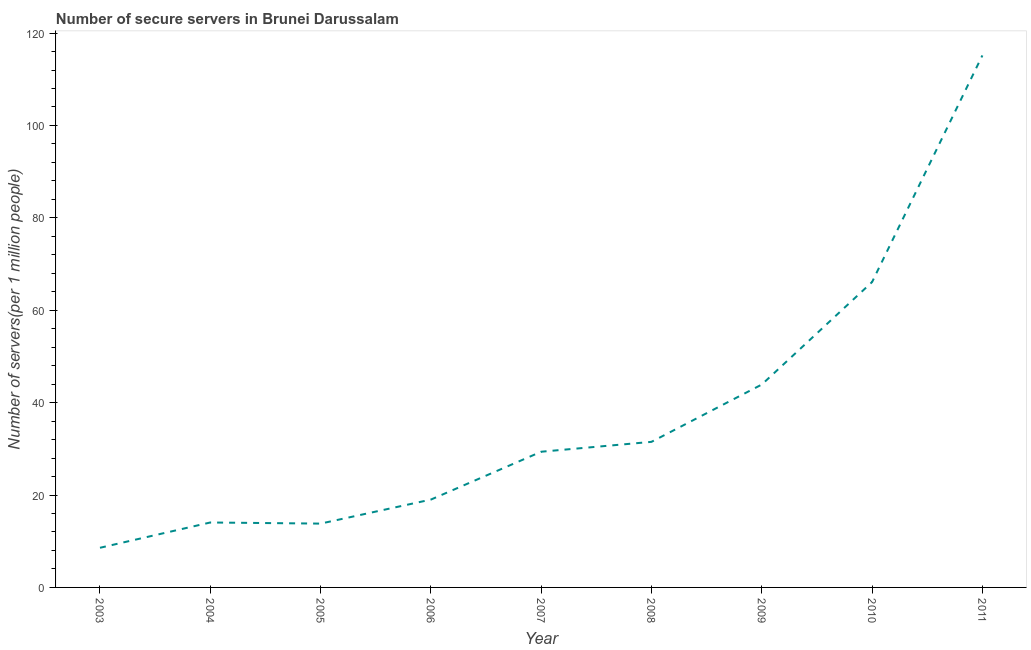What is the number of secure internet servers in 2005?
Provide a succinct answer. 13.82. Across all years, what is the maximum number of secure internet servers?
Provide a succinct answer. 115.16. Across all years, what is the minimum number of secure internet servers?
Offer a very short reply. 8.58. In which year was the number of secure internet servers minimum?
Your response must be concise. 2003. What is the sum of the number of secure internet servers?
Your answer should be compact. 341.54. What is the difference between the number of secure internet servers in 2005 and 2006?
Your answer should be compact. -5.2. What is the average number of secure internet servers per year?
Offer a terse response. 37.95. What is the median number of secure internet servers?
Offer a terse response. 29.38. Do a majority of the years between 2009 and 2007 (inclusive) have number of secure internet servers greater than 32 ?
Offer a very short reply. No. What is the ratio of the number of secure internet servers in 2004 to that in 2007?
Give a very brief answer. 0.48. Is the number of secure internet servers in 2004 less than that in 2005?
Offer a very short reply. No. Is the difference between the number of secure internet servers in 2003 and 2006 greater than the difference between any two years?
Ensure brevity in your answer.  No. What is the difference between the highest and the second highest number of secure internet servers?
Make the answer very short. 49.05. What is the difference between the highest and the lowest number of secure internet servers?
Offer a terse response. 106.58. In how many years, is the number of secure internet servers greater than the average number of secure internet servers taken over all years?
Your answer should be very brief. 3. How many lines are there?
Give a very brief answer. 1. How many years are there in the graph?
Your answer should be compact. 9. Does the graph contain any zero values?
Offer a terse response. No. What is the title of the graph?
Your response must be concise. Number of secure servers in Brunei Darussalam. What is the label or title of the X-axis?
Your response must be concise. Year. What is the label or title of the Y-axis?
Provide a short and direct response. Number of servers(per 1 million people). What is the Number of servers(per 1 million people) in 2003?
Your response must be concise. 8.58. What is the Number of servers(per 1 million people) in 2004?
Offer a very short reply. 14.06. What is the Number of servers(per 1 million people) in 2005?
Provide a succinct answer. 13.82. What is the Number of servers(per 1 million people) of 2006?
Provide a succinct answer. 19.01. What is the Number of servers(per 1 million people) in 2007?
Make the answer very short. 29.38. What is the Number of servers(per 1 million people) in 2008?
Ensure brevity in your answer.  31.51. What is the Number of servers(per 1 million people) in 2009?
Your answer should be very brief. 43.92. What is the Number of servers(per 1 million people) in 2010?
Make the answer very short. 66.11. What is the Number of servers(per 1 million people) in 2011?
Your answer should be compact. 115.16. What is the difference between the Number of servers(per 1 million people) in 2003 and 2004?
Your answer should be compact. -5.47. What is the difference between the Number of servers(per 1 million people) in 2003 and 2005?
Offer a terse response. -5.23. What is the difference between the Number of servers(per 1 million people) in 2003 and 2006?
Provide a short and direct response. -10.43. What is the difference between the Number of servers(per 1 million people) in 2003 and 2007?
Your response must be concise. -20.79. What is the difference between the Number of servers(per 1 million people) in 2003 and 2008?
Provide a succinct answer. -22.93. What is the difference between the Number of servers(per 1 million people) in 2003 and 2009?
Provide a short and direct response. -35.34. What is the difference between the Number of servers(per 1 million people) in 2003 and 2010?
Keep it short and to the point. -57.52. What is the difference between the Number of servers(per 1 million people) in 2003 and 2011?
Offer a terse response. -106.58. What is the difference between the Number of servers(per 1 million people) in 2004 and 2005?
Keep it short and to the point. 0.24. What is the difference between the Number of servers(per 1 million people) in 2004 and 2006?
Offer a terse response. -4.96. What is the difference between the Number of servers(per 1 million people) in 2004 and 2007?
Make the answer very short. -15.32. What is the difference between the Number of servers(per 1 million people) in 2004 and 2008?
Make the answer very short. -17.46. What is the difference between the Number of servers(per 1 million people) in 2004 and 2009?
Your answer should be compact. -29.86. What is the difference between the Number of servers(per 1 million people) in 2004 and 2010?
Keep it short and to the point. -52.05. What is the difference between the Number of servers(per 1 million people) in 2004 and 2011?
Ensure brevity in your answer.  -101.1. What is the difference between the Number of servers(per 1 million people) in 2005 and 2006?
Offer a terse response. -5.2. What is the difference between the Number of servers(per 1 million people) in 2005 and 2007?
Offer a terse response. -15.56. What is the difference between the Number of servers(per 1 million people) in 2005 and 2008?
Your answer should be compact. -17.7. What is the difference between the Number of servers(per 1 million people) in 2005 and 2009?
Provide a succinct answer. -30.1. What is the difference between the Number of servers(per 1 million people) in 2005 and 2010?
Your answer should be compact. -52.29. What is the difference between the Number of servers(per 1 million people) in 2005 and 2011?
Provide a succinct answer. -101.34. What is the difference between the Number of servers(per 1 million people) in 2006 and 2007?
Make the answer very short. -10.36. What is the difference between the Number of servers(per 1 million people) in 2006 and 2008?
Offer a terse response. -12.5. What is the difference between the Number of servers(per 1 million people) in 2006 and 2009?
Give a very brief answer. -24.9. What is the difference between the Number of servers(per 1 million people) in 2006 and 2010?
Your answer should be compact. -47.09. What is the difference between the Number of servers(per 1 million people) in 2006 and 2011?
Provide a short and direct response. -96.15. What is the difference between the Number of servers(per 1 million people) in 2007 and 2008?
Your response must be concise. -2.14. What is the difference between the Number of servers(per 1 million people) in 2007 and 2009?
Your response must be concise. -14.54. What is the difference between the Number of servers(per 1 million people) in 2007 and 2010?
Provide a short and direct response. -36.73. What is the difference between the Number of servers(per 1 million people) in 2007 and 2011?
Provide a succinct answer. -85.78. What is the difference between the Number of servers(per 1 million people) in 2008 and 2009?
Your response must be concise. -12.4. What is the difference between the Number of servers(per 1 million people) in 2008 and 2010?
Ensure brevity in your answer.  -34.59. What is the difference between the Number of servers(per 1 million people) in 2008 and 2011?
Make the answer very short. -83.65. What is the difference between the Number of servers(per 1 million people) in 2009 and 2010?
Provide a short and direct response. -22.19. What is the difference between the Number of servers(per 1 million people) in 2009 and 2011?
Your answer should be very brief. -71.24. What is the difference between the Number of servers(per 1 million people) in 2010 and 2011?
Ensure brevity in your answer.  -49.05. What is the ratio of the Number of servers(per 1 million people) in 2003 to that in 2004?
Your answer should be compact. 0.61. What is the ratio of the Number of servers(per 1 million people) in 2003 to that in 2005?
Offer a terse response. 0.62. What is the ratio of the Number of servers(per 1 million people) in 2003 to that in 2006?
Give a very brief answer. 0.45. What is the ratio of the Number of servers(per 1 million people) in 2003 to that in 2007?
Your answer should be very brief. 0.29. What is the ratio of the Number of servers(per 1 million people) in 2003 to that in 2008?
Provide a short and direct response. 0.27. What is the ratio of the Number of servers(per 1 million people) in 2003 to that in 2009?
Provide a short and direct response. 0.2. What is the ratio of the Number of servers(per 1 million people) in 2003 to that in 2010?
Your answer should be compact. 0.13. What is the ratio of the Number of servers(per 1 million people) in 2003 to that in 2011?
Your response must be concise. 0.07. What is the ratio of the Number of servers(per 1 million people) in 2004 to that in 2006?
Keep it short and to the point. 0.74. What is the ratio of the Number of servers(per 1 million people) in 2004 to that in 2007?
Your answer should be compact. 0.48. What is the ratio of the Number of servers(per 1 million people) in 2004 to that in 2008?
Offer a terse response. 0.45. What is the ratio of the Number of servers(per 1 million people) in 2004 to that in 2009?
Your answer should be very brief. 0.32. What is the ratio of the Number of servers(per 1 million people) in 2004 to that in 2010?
Give a very brief answer. 0.21. What is the ratio of the Number of servers(per 1 million people) in 2004 to that in 2011?
Give a very brief answer. 0.12. What is the ratio of the Number of servers(per 1 million people) in 2005 to that in 2006?
Offer a terse response. 0.73. What is the ratio of the Number of servers(per 1 million people) in 2005 to that in 2007?
Your answer should be compact. 0.47. What is the ratio of the Number of servers(per 1 million people) in 2005 to that in 2008?
Offer a terse response. 0.44. What is the ratio of the Number of servers(per 1 million people) in 2005 to that in 2009?
Provide a short and direct response. 0.32. What is the ratio of the Number of servers(per 1 million people) in 2005 to that in 2010?
Your response must be concise. 0.21. What is the ratio of the Number of servers(per 1 million people) in 2005 to that in 2011?
Your answer should be very brief. 0.12. What is the ratio of the Number of servers(per 1 million people) in 2006 to that in 2007?
Your response must be concise. 0.65. What is the ratio of the Number of servers(per 1 million people) in 2006 to that in 2008?
Your answer should be very brief. 0.6. What is the ratio of the Number of servers(per 1 million people) in 2006 to that in 2009?
Offer a terse response. 0.43. What is the ratio of the Number of servers(per 1 million people) in 2006 to that in 2010?
Your answer should be very brief. 0.29. What is the ratio of the Number of servers(per 1 million people) in 2006 to that in 2011?
Keep it short and to the point. 0.17. What is the ratio of the Number of servers(per 1 million people) in 2007 to that in 2008?
Your response must be concise. 0.93. What is the ratio of the Number of servers(per 1 million people) in 2007 to that in 2009?
Your response must be concise. 0.67. What is the ratio of the Number of servers(per 1 million people) in 2007 to that in 2010?
Keep it short and to the point. 0.44. What is the ratio of the Number of servers(per 1 million people) in 2007 to that in 2011?
Your answer should be very brief. 0.26. What is the ratio of the Number of servers(per 1 million people) in 2008 to that in 2009?
Ensure brevity in your answer.  0.72. What is the ratio of the Number of servers(per 1 million people) in 2008 to that in 2010?
Provide a short and direct response. 0.48. What is the ratio of the Number of servers(per 1 million people) in 2008 to that in 2011?
Offer a terse response. 0.27. What is the ratio of the Number of servers(per 1 million people) in 2009 to that in 2010?
Give a very brief answer. 0.66. What is the ratio of the Number of servers(per 1 million people) in 2009 to that in 2011?
Your response must be concise. 0.38. What is the ratio of the Number of servers(per 1 million people) in 2010 to that in 2011?
Your answer should be very brief. 0.57. 